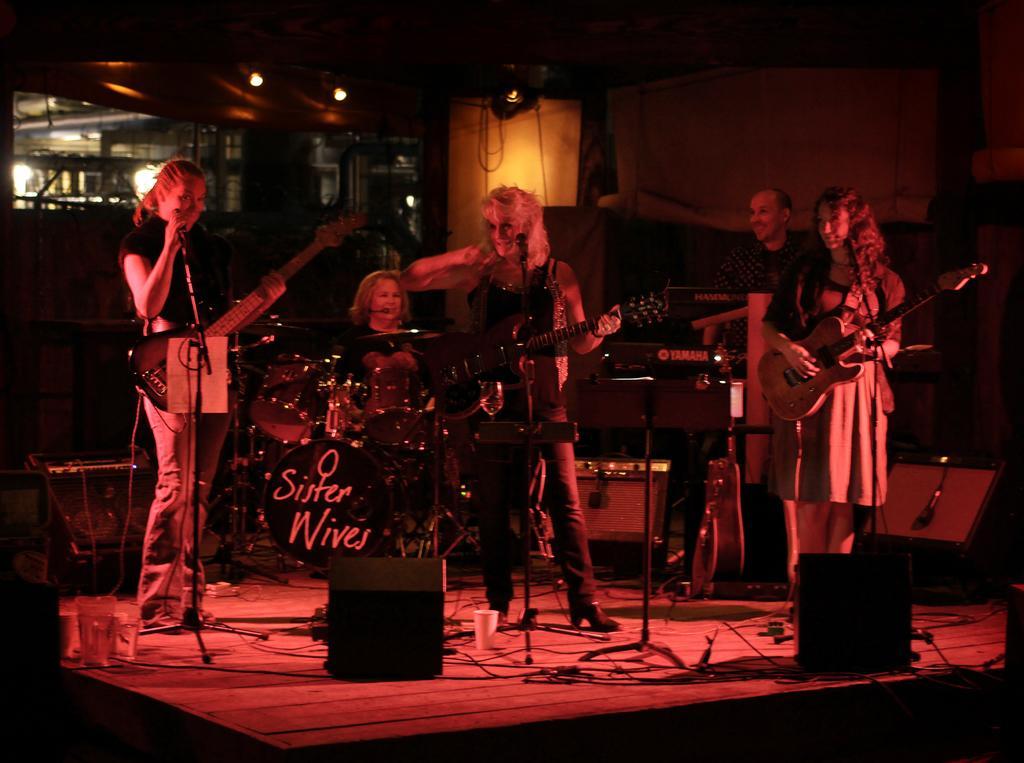Could you give a brief overview of what you see in this image? In this picture there are five people. There is a woman holding a guitar and a mic. There is also another woman who is sitting on the chair. There is a woman who is also holding a guitar. There is a man who is standing at the back. There is a person who is holding a guitar. There is a cup and other musical instruments at the background. There is a light and some bottles. 